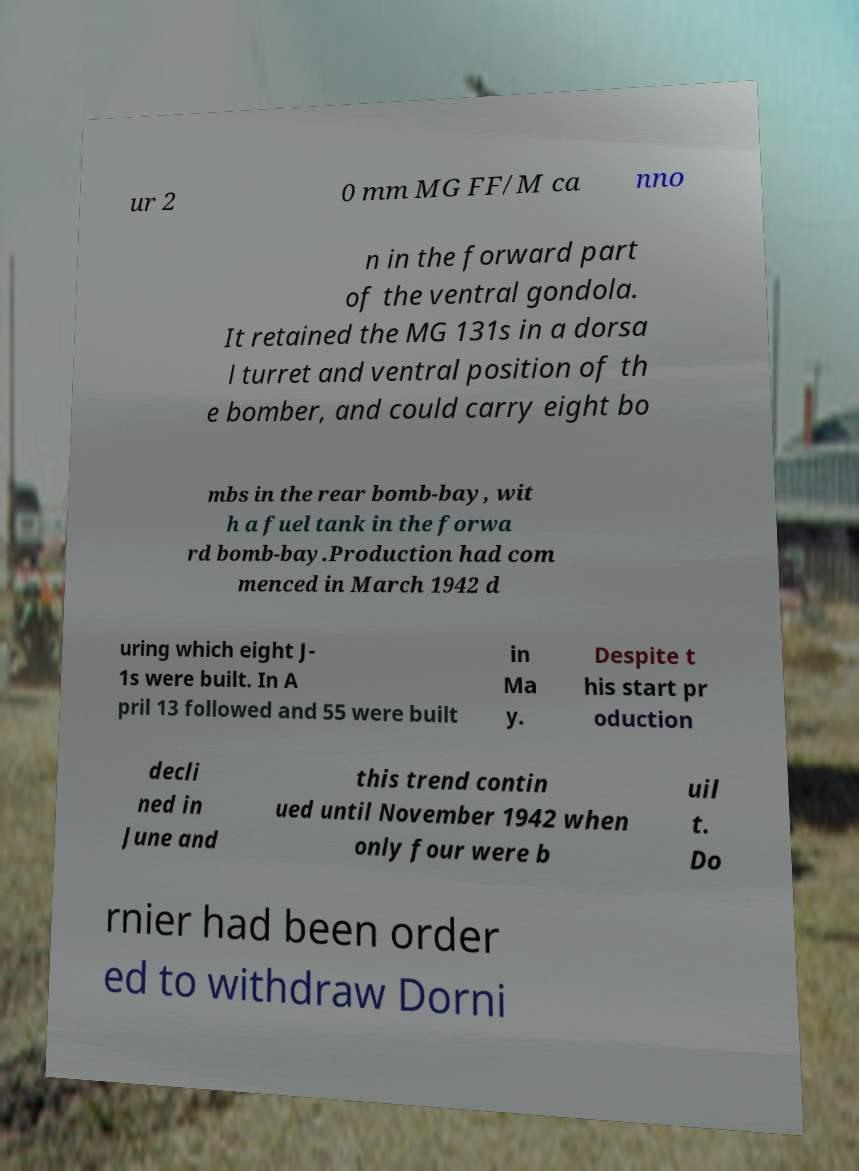Can you read and provide the text displayed in the image?This photo seems to have some interesting text. Can you extract and type it out for me? ur 2 0 mm MG FF/M ca nno n in the forward part of the ventral gondola. It retained the MG 131s in a dorsa l turret and ventral position of th e bomber, and could carry eight bo mbs in the rear bomb-bay, wit h a fuel tank in the forwa rd bomb-bay.Production had com menced in March 1942 d uring which eight J- 1s were built. In A pril 13 followed and 55 were built in Ma y. Despite t his start pr oduction decli ned in June and this trend contin ued until November 1942 when only four were b uil t. Do rnier had been order ed to withdraw Dorni 